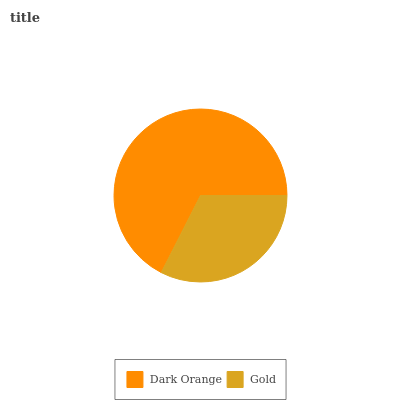Is Gold the minimum?
Answer yes or no. Yes. Is Dark Orange the maximum?
Answer yes or no. Yes. Is Gold the maximum?
Answer yes or no. No. Is Dark Orange greater than Gold?
Answer yes or no. Yes. Is Gold less than Dark Orange?
Answer yes or no. Yes. Is Gold greater than Dark Orange?
Answer yes or no. No. Is Dark Orange less than Gold?
Answer yes or no. No. Is Dark Orange the high median?
Answer yes or no. Yes. Is Gold the low median?
Answer yes or no. Yes. Is Gold the high median?
Answer yes or no. No. Is Dark Orange the low median?
Answer yes or no. No. 